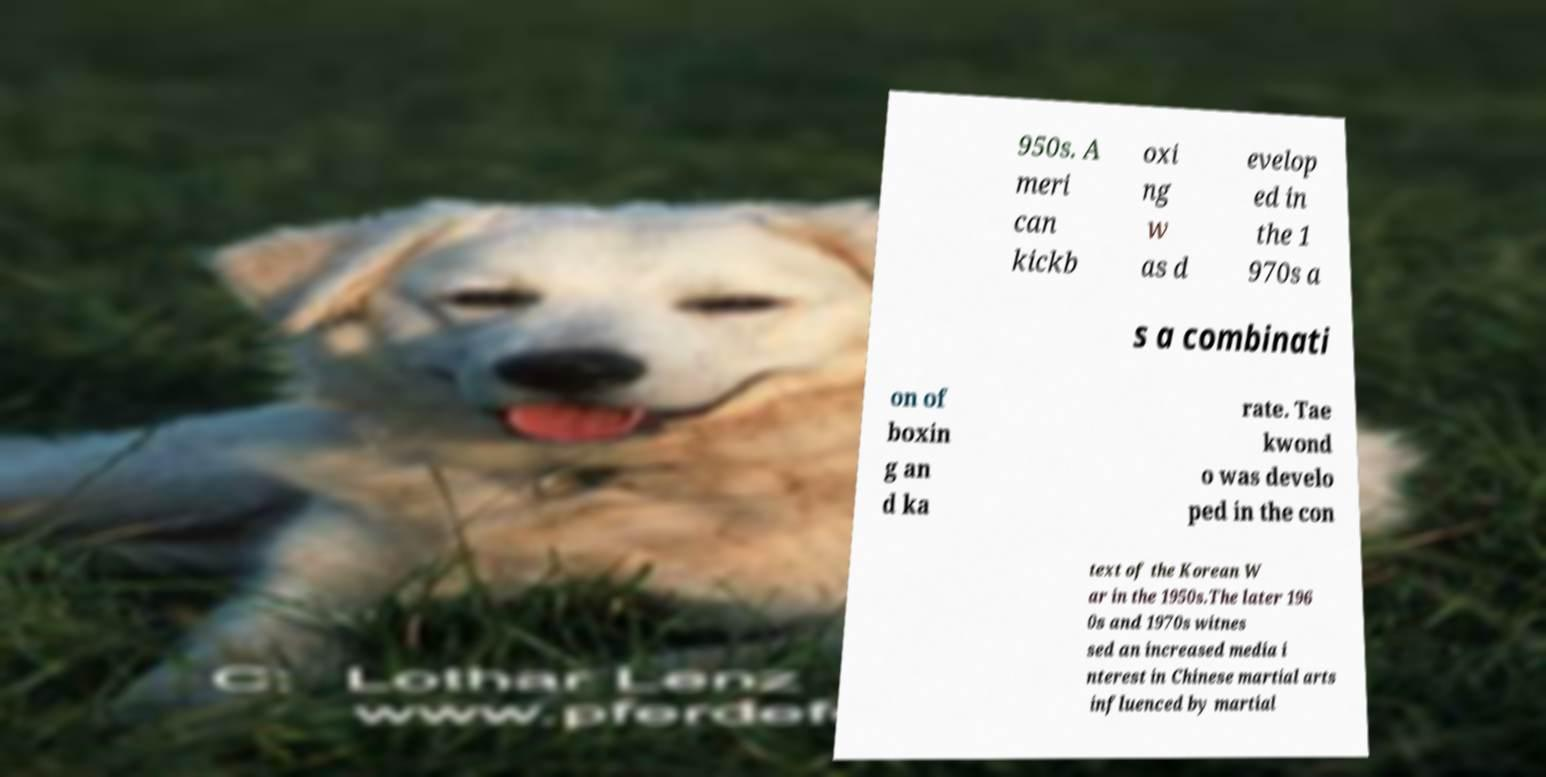Please read and relay the text visible in this image. What does it say? 950s. A meri can kickb oxi ng w as d evelop ed in the 1 970s a s a combinati on of boxin g an d ka rate. Tae kwond o was develo ped in the con text of the Korean W ar in the 1950s.The later 196 0s and 1970s witnes sed an increased media i nterest in Chinese martial arts influenced by martial 